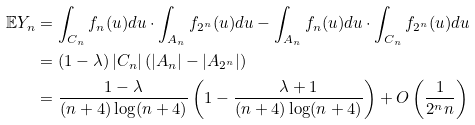<formula> <loc_0><loc_0><loc_500><loc_500>\mathbb { E } Y _ { n } & = \int _ { C _ { n } } f _ { n } ( u ) d u \cdot \int _ { A _ { n } } f _ { 2 ^ { n } } ( u ) d u - \int _ { A _ { n } } f _ { n } ( u ) d u \cdot \int _ { C _ { n } } f _ { 2 ^ { n } } ( u ) d u \\ & = ( 1 - \lambda ) \left | C _ { n } \right | \left ( \left | A _ { n } \right | - \left | A _ { 2 ^ { n } } \right | \right ) \\ & = \frac { 1 - \lambda } { ( n + 4 ) \log ( n + 4 ) } \left ( 1 - \frac { \lambda + 1 } { ( n + 4 ) \log ( n + 4 ) } \right ) + O \left ( \frac { 1 } { 2 ^ { n } n } \right )</formula> 